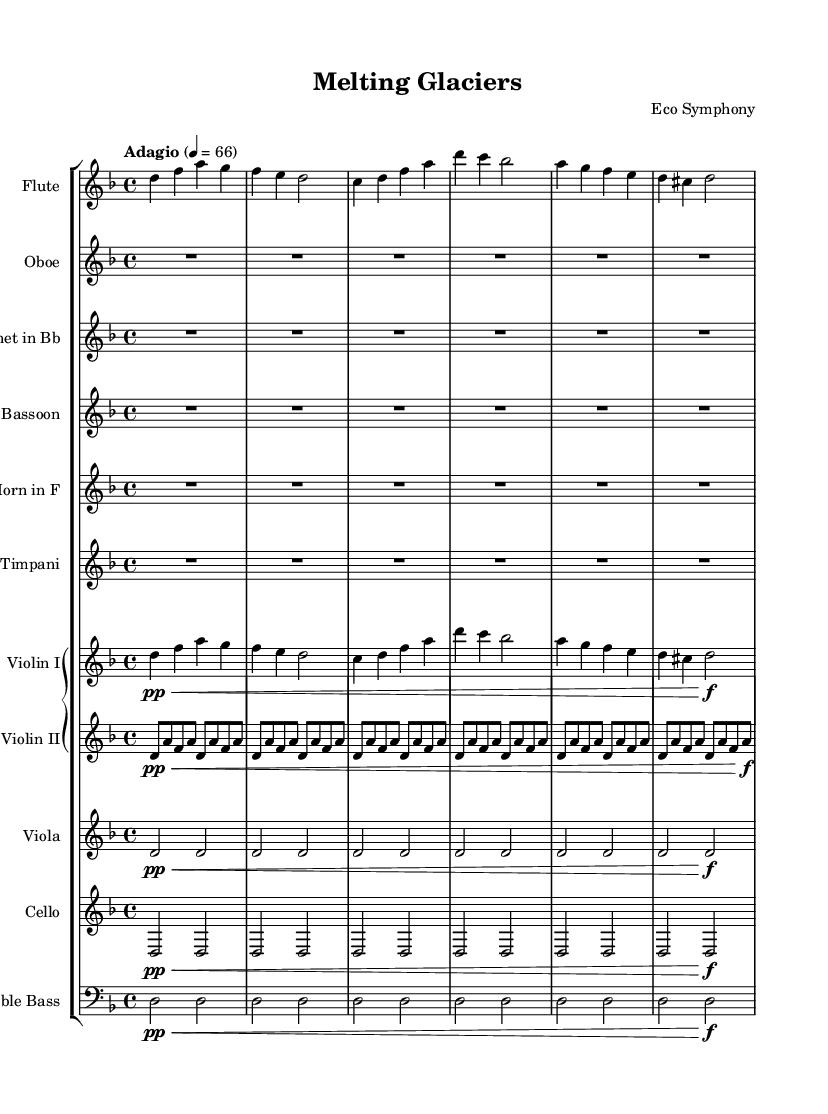What is the key signature of this music? The key signature is indicated before the time signature, showing two flats. This specifies that the piece is in D minor.
Answer: D minor What is the time signature of this piece? The time signature is shown as 4/4, which indicates four beats per measure, with a quarter note receiving one beat.
Answer: 4/4 What is the tempo marking at the beginning of the score? The tempo marking expresses how fast the piece should be played. It states "Adagio" with a tempo of 66, suggesting a slow pace.
Answer: Adagio 66 How many instruments are in the score? The score contains a total of ten different instruments listed in the staff group: Flute, Oboe, Clarinet, Bassoon, Horn, Timpani, Violin I, Violin II, Viola, Cello, and Double Bass. Counting these instruments gives us the total.
Answer: Ten Which instrument has a rest for the entire measure (bar)? The Oboe, Clarinet, Bassoon, Horn, and Timpani all have a whole rest for the first six measures, indicating that they do not play. This is confirmed by the "R1*6" notation for these instruments.
Answer: Oboe Is the dynamics indication present in the first violin part? Yes, the first violin part has dynamics indicated. It starts with "pp" for very soft, and there is a "f" marking indicating a change to loud later in the passage. This shows the expressive capability required.
Answer: Yes What emotional theme does the title "Melting Glaciers" suggest? The title suggests an emotional connection to nature and climate change. As glaciers are melting due to climate issues, the composition may evoke feelings of loss or urgency about environmental concerns.
Answer: Environmental urgency 